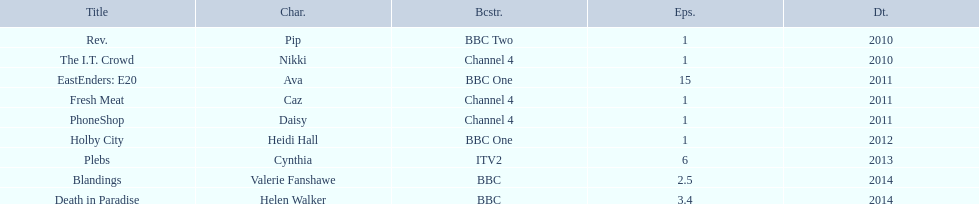How many episodes did sophie colquhoun star in on rev.? 1. What character did she play on phoneshop? Daisy. What role did she play on itv2? Cynthia. 